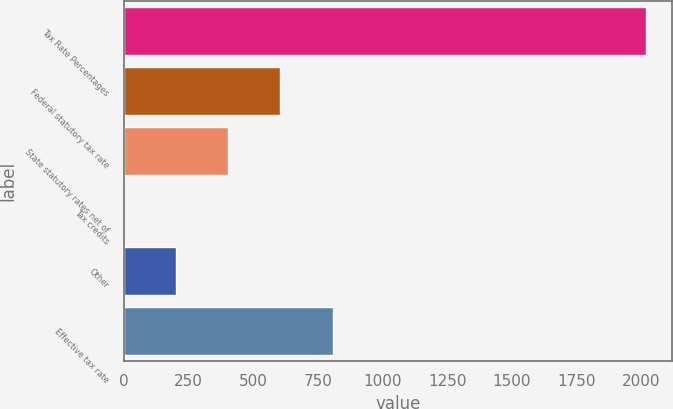<chart> <loc_0><loc_0><loc_500><loc_500><bar_chart><fcel>Tax Rate Percentages<fcel>Federal statutory tax rate<fcel>State statutory rates net of<fcel>Tax credits<fcel>Other<fcel>Effective tax rate<nl><fcel>2017<fcel>605.17<fcel>403.48<fcel>0.1<fcel>201.79<fcel>806.86<nl></chart> 